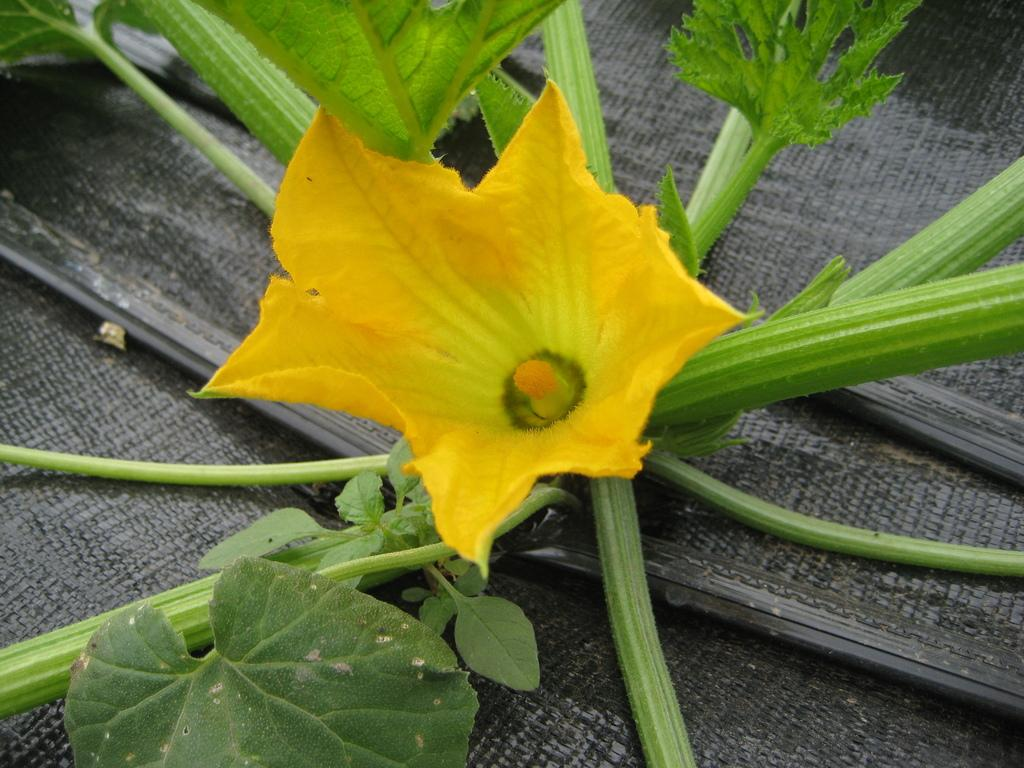What is the main subject in the center of the image? There is a flower in the center of the image. What else can be seen in the image besides the flower? There are leaves in the image. What part of the flower is being measured in the image? There is no indication in the image that any part of the flower is being measured. 